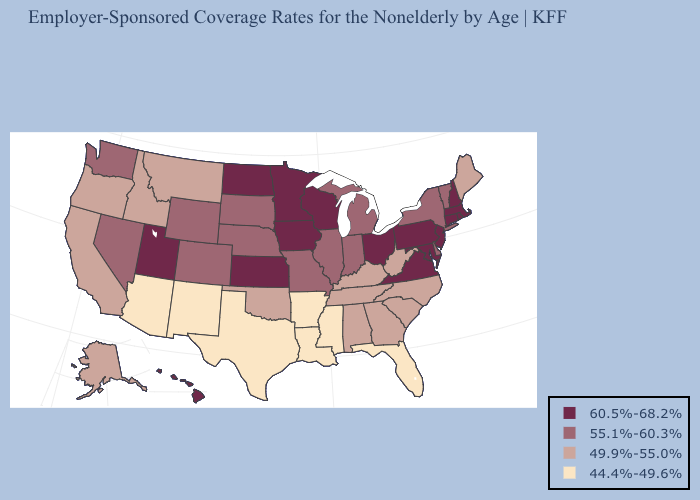Does the first symbol in the legend represent the smallest category?
Keep it brief. No. What is the value of Alabama?
Be succinct. 49.9%-55.0%. What is the value of Montana?
Be succinct. 49.9%-55.0%. What is the highest value in states that border Texas?
Give a very brief answer. 49.9%-55.0%. Among the states that border Tennessee , which have the highest value?
Give a very brief answer. Virginia. Does Ohio have the highest value in the USA?
Concise answer only. Yes. What is the value of Indiana?
Short answer required. 55.1%-60.3%. Which states hav the highest value in the South?
Write a very short answer. Maryland, Virginia. What is the lowest value in the Northeast?
Answer briefly. 49.9%-55.0%. Name the states that have a value in the range 55.1%-60.3%?
Answer briefly. Colorado, Delaware, Illinois, Indiana, Michigan, Missouri, Nebraska, Nevada, New York, South Dakota, Vermont, Washington, Wyoming. Name the states that have a value in the range 49.9%-55.0%?
Concise answer only. Alabama, Alaska, California, Georgia, Idaho, Kentucky, Maine, Montana, North Carolina, Oklahoma, Oregon, South Carolina, Tennessee, West Virginia. What is the highest value in the Northeast ?
Write a very short answer. 60.5%-68.2%. What is the value of Indiana?
Keep it brief. 55.1%-60.3%. Among the states that border Michigan , does Indiana have the lowest value?
Give a very brief answer. Yes. Which states hav the highest value in the Northeast?
Answer briefly. Connecticut, Massachusetts, New Hampshire, New Jersey, Pennsylvania, Rhode Island. 